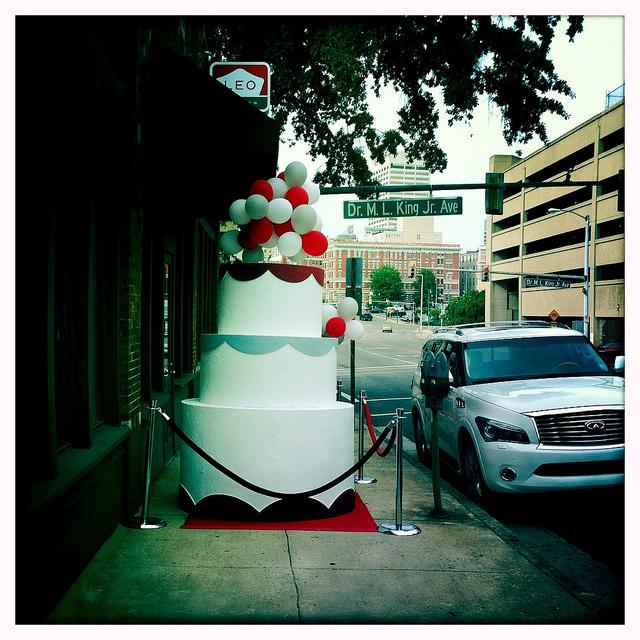Is that a real cake?
Give a very brief answer. No. What color are the balloons?
Be succinct. Red and white. How many tiers are on the cake?
Give a very brief answer. 3. 